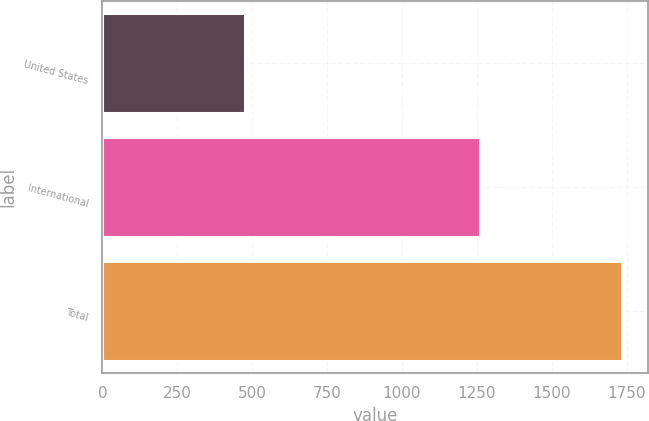<chart> <loc_0><loc_0><loc_500><loc_500><bar_chart><fcel>United States<fcel>International<fcel>Total<nl><fcel>475<fcel>1260<fcel>1735<nl></chart> 